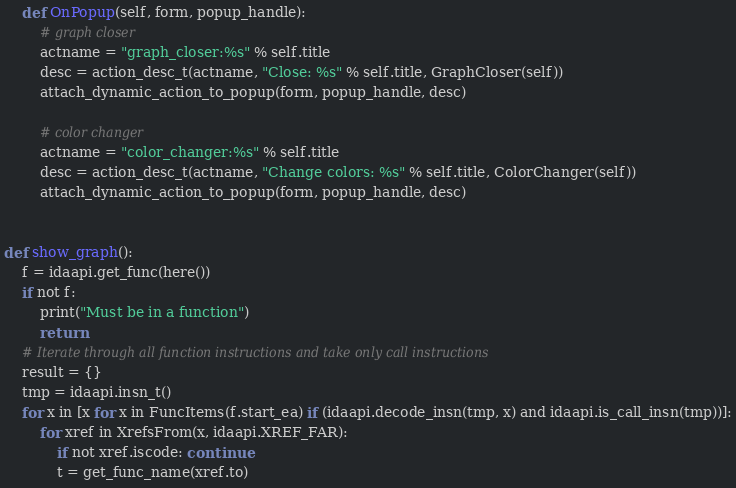Convert code to text. <code><loc_0><loc_0><loc_500><loc_500><_Python_>
    def OnPopup(self, form, popup_handle):
        # graph closer
        actname = "graph_closer:%s" % self.title
        desc = action_desc_t(actname, "Close: %s" % self.title, GraphCloser(self))
        attach_dynamic_action_to_popup(form, popup_handle, desc)

        # color changer
        actname = "color_changer:%s" % self.title
        desc = action_desc_t(actname, "Change colors: %s" % self.title, ColorChanger(self))
        attach_dynamic_action_to_popup(form, popup_handle, desc)


def show_graph():
    f = idaapi.get_func(here())
    if not f:
        print("Must be in a function")
        return
    # Iterate through all function instructions and take only call instructions
    result = {}
    tmp = idaapi.insn_t()
    for x in [x for x in FuncItems(f.start_ea) if (idaapi.decode_insn(tmp, x) and idaapi.is_call_insn(tmp))]:
        for xref in XrefsFrom(x, idaapi.XREF_FAR):
            if not xref.iscode: continue
            t = get_func_name(xref.to)</code> 